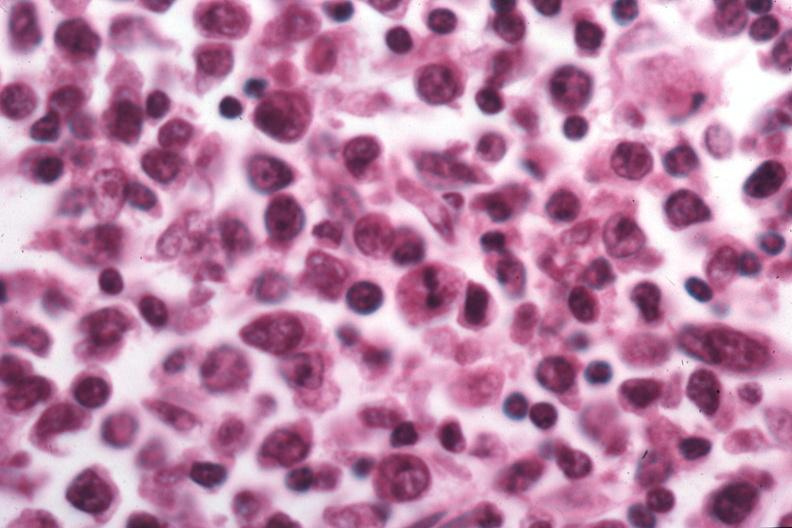s lymph node present?
Answer the question using a single word or phrase. Yes 